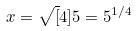Convert formula to latex. <formula><loc_0><loc_0><loc_500><loc_500>x = \sqrt { [ } 4 ] { 5 } = 5 ^ { 1 / 4 }</formula> 